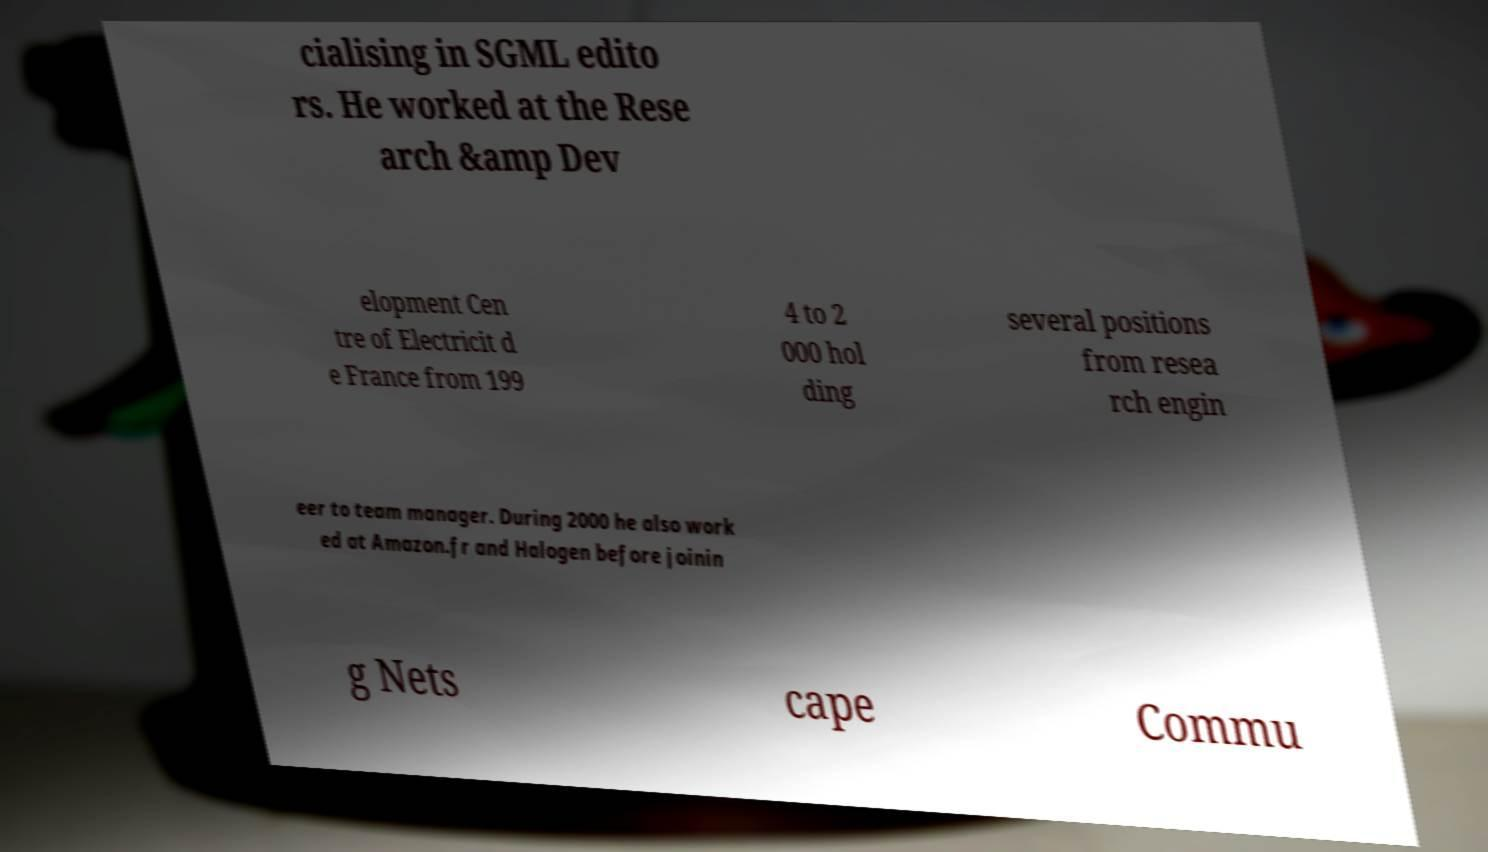Please read and relay the text visible in this image. What does it say? cialising in SGML edito rs. He worked at the Rese arch &amp Dev elopment Cen tre of Electricit d e France from 199 4 to 2 000 hol ding several positions from resea rch engin eer to team manager. During 2000 he also work ed at Amazon.fr and Halogen before joinin g Nets cape Commu 